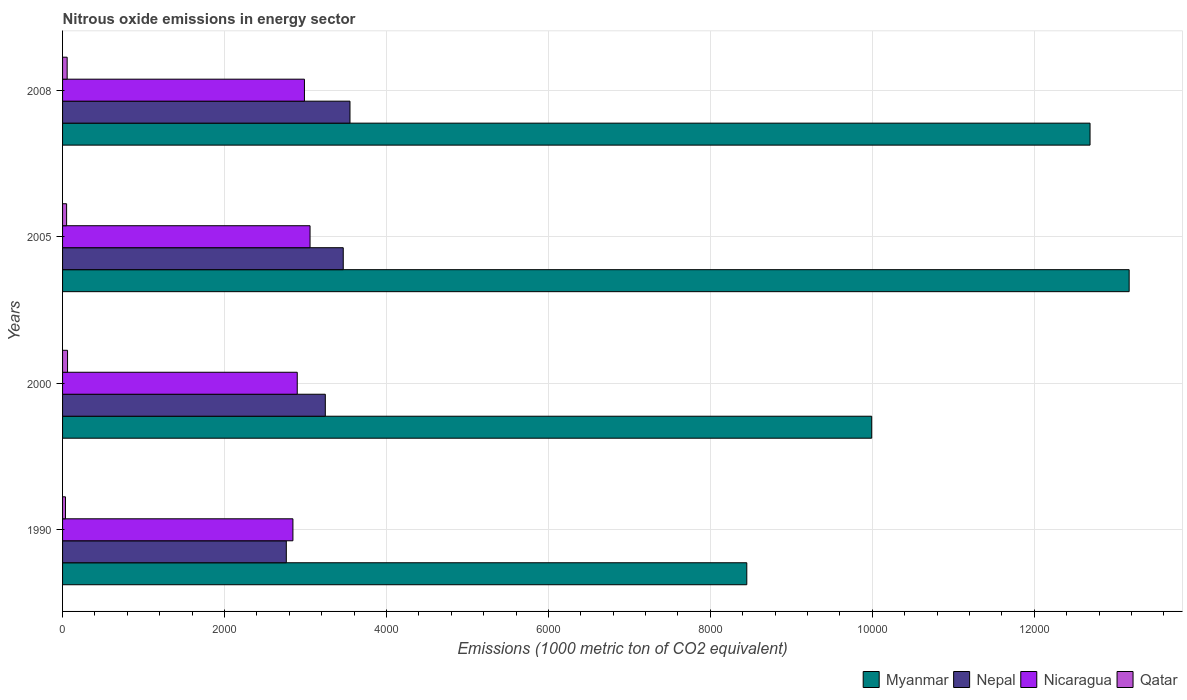How many different coloured bars are there?
Make the answer very short. 4. Are the number of bars per tick equal to the number of legend labels?
Provide a short and direct response. Yes. How many bars are there on the 4th tick from the bottom?
Provide a succinct answer. 4. What is the amount of nitrous oxide emitted in Nepal in 2008?
Your answer should be compact. 3549.4. Across all years, what is the maximum amount of nitrous oxide emitted in Nepal?
Your response must be concise. 3549.4. Across all years, what is the minimum amount of nitrous oxide emitted in Nicaragua?
Provide a succinct answer. 2844.7. In which year was the amount of nitrous oxide emitted in Qatar minimum?
Give a very brief answer. 1990. What is the total amount of nitrous oxide emitted in Nicaragua in the graph?
Provide a succinct answer. 1.18e+04. What is the difference between the amount of nitrous oxide emitted in Nicaragua in 2000 and that in 2005?
Your answer should be compact. -157.9. What is the difference between the amount of nitrous oxide emitted in Myanmar in 1990 and the amount of nitrous oxide emitted in Nicaragua in 2000?
Keep it short and to the point. 5551.5. What is the average amount of nitrous oxide emitted in Nepal per year?
Your answer should be compact. 3255.85. In the year 1990, what is the difference between the amount of nitrous oxide emitted in Nicaragua and amount of nitrous oxide emitted in Qatar?
Keep it short and to the point. 2808.7. In how many years, is the amount of nitrous oxide emitted in Qatar greater than 12000 1000 metric ton?
Give a very brief answer. 0. What is the ratio of the amount of nitrous oxide emitted in Nepal in 1990 to that in 2008?
Give a very brief answer. 0.78. Is the difference between the amount of nitrous oxide emitted in Nicaragua in 1990 and 2008 greater than the difference between the amount of nitrous oxide emitted in Qatar in 1990 and 2008?
Your answer should be very brief. No. What is the difference between the highest and the second highest amount of nitrous oxide emitted in Nicaragua?
Your answer should be very brief. 69.2. What is the difference between the highest and the lowest amount of nitrous oxide emitted in Myanmar?
Provide a short and direct response. 4721.9. In how many years, is the amount of nitrous oxide emitted in Nepal greater than the average amount of nitrous oxide emitted in Nepal taken over all years?
Your answer should be compact. 2. Is the sum of the amount of nitrous oxide emitted in Nicaragua in 2005 and 2008 greater than the maximum amount of nitrous oxide emitted in Myanmar across all years?
Your answer should be very brief. No. What does the 4th bar from the top in 2000 represents?
Offer a terse response. Myanmar. What does the 4th bar from the bottom in 2008 represents?
Offer a terse response. Qatar. What is the difference between two consecutive major ticks on the X-axis?
Your answer should be very brief. 2000. Are the values on the major ticks of X-axis written in scientific E-notation?
Ensure brevity in your answer.  No. Does the graph contain any zero values?
Make the answer very short. No. What is the title of the graph?
Offer a terse response. Nitrous oxide emissions in energy sector. What is the label or title of the X-axis?
Offer a terse response. Emissions (1000 metric ton of CO2 equivalent). What is the Emissions (1000 metric ton of CO2 equivalent) in Myanmar in 1990?
Offer a terse response. 8449.7. What is the Emissions (1000 metric ton of CO2 equivalent) in Nepal in 1990?
Make the answer very short. 2763. What is the Emissions (1000 metric ton of CO2 equivalent) in Nicaragua in 1990?
Give a very brief answer. 2844.7. What is the Emissions (1000 metric ton of CO2 equivalent) in Qatar in 1990?
Offer a terse response. 36. What is the Emissions (1000 metric ton of CO2 equivalent) of Myanmar in 2000?
Your answer should be compact. 9992.2. What is the Emissions (1000 metric ton of CO2 equivalent) of Nepal in 2000?
Provide a succinct answer. 3244.8. What is the Emissions (1000 metric ton of CO2 equivalent) in Nicaragua in 2000?
Provide a succinct answer. 2898.2. What is the Emissions (1000 metric ton of CO2 equivalent) of Qatar in 2000?
Make the answer very short. 61.6. What is the Emissions (1000 metric ton of CO2 equivalent) in Myanmar in 2005?
Your answer should be compact. 1.32e+04. What is the Emissions (1000 metric ton of CO2 equivalent) of Nepal in 2005?
Keep it short and to the point. 3466.2. What is the Emissions (1000 metric ton of CO2 equivalent) of Nicaragua in 2005?
Your answer should be very brief. 3056.1. What is the Emissions (1000 metric ton of CO2 equivalent) in Qatar in 2005?
Keep it short and to the point. 49.9. What is the Emissions (1000 metric ton of CO2 equivalent) in Myanmar in 2008?
Make the answer very short. 1.27e+04. What is the Emissions (1000 metric ton of CO2 equivalent) in Nepal in 2008?
Provide a short and direct response. 3549.4. What is the Emissions (1000 metric ton of CO2 equivalent) in Nicaragua in 2008?
Offer a very short reply. 2986.9. What is the Emissions (1000 metric ton of CO2 equivalent) in Qatar in 2008?
Offer a very short reply. 56.6. Across all years, what is the maximum Emissions (1000 metric ton of CO2 equivalent) of Myanmar?
Your answer should be very brief. 1.32e+04. Across all years, what is the maximum Emissions (1000 metric ton of CO2 equivalent) in Nepal?
Your answer should be compact. 3549.4. Across all years, what is the maximum Emissions (1000 metric ton of CO2 equivalent) of Nicaragua?
Provide a succinct answer. 3056.1. Across all years, what is the maximum Emissions (1000 metric ton of CO2 equivalent) of Qatar?
Offer a terse response. 61.6. Across all years, what is the minimum Emissions (1000 metric ton of CO2 equivalent) of Myanmar?
Ensure brevity in your answer.  8449.7. Across all years, what is the minimum Emissions (1000 metric ton of CO2 equivalent) of Nepal?
Your response must be concise. 2763. Across all years, what is the minimum Emissions (1000 metric ton of CO2 equivalent) in Nicaragua?
Your answer should be compact. 2844.7. Across all years, what is the minimum Emissions (1000 metric ton of CO2 equivalent) of Qatar?
Keep it short and to the point. 36. What is the total Emissions (1000 metric ton of CO2 equivalent) in Myanmar in the graph?
Your answer should be very brief. 4.43e+04. What is the total Emissions (1000 metric ton of CO2 equivalent) in Nepal in the graph?
Provide a succinct answer. 1.30e+04. What is the total Emissions (1000 metric ton of CO2 equivalent) of Nicaragua in the graph?
Give a very brief answer. 1.18e+04. What is the total Emissions (1000 metric ton of CO2 equivalent) of Qatar in the graph?
Provide a succinct answer. 204.1. What is the difference between the Emissions (1000 metric ton of CO2 equivalent) in Myanmar in 1990 and that in 2000?
Ensure brevity in your answer.  -1542.5. What is the difference between the Emissions (1000 metric ton of CO2 equivalent) of Nepal in 1990 and that in 2000?
Your answer should be compact. -481.8. What is the difference between the Emissions (1000 metric ton of CO2 equivalent) in Nicaragua in 1990 and that in 2000?
Your response must be concise. -53.5. What is the difference between the Emissions (1000 metric ton of CO2 equivalent) in Qatar in 1990 and that in 2000?
Your response must be concise. -25.6. What is the difference between the Emissions (1000 metric ton of CO2 equivalent) in Myanmar in 1990 and that in 2005?
Offer a terse response. -4721.9. What is the difference between the Emissions (1000 metric ton of CO2 equivalent) of Nepal in 1990 and that in 2005?
Provide a succinct answer. -703.2. What is the difference between the Emissions (1000 metric ton of CO2 equivalent) in Nicaragua in 1990 and that in 2005?
Ensure brevity in your answer.  -211.4. What is the difference between the Emissions (1000 metric ton of CO2 equivalent) in Qatar in 1990 and that in 2005?
Ensure brevity in your answer.  -13.9. What is the difference between the Emissions (1000 metric ton of CO2 equivalent) of Myanmar in 1990 and that in 2008?
Provide a succinct answer. -4238.8. What is the difference between the Emissions (1000 metric ton of CO2 equivalent) of Nepal in 1990 and that in 2008?
Offer a very short reply. -786.4. What is the difference between the Emissions (1000 metric ton of CO2 equivalent) of Nicaragua in 1990 and that in 2008?
Offer a terse response. -142.2. What is the difference between the Emissions (1000 metric ton of CO2 equivalent) in Qatar in 1990 and that in 2008?
Offer a very short reply. -20.6. What is the difference between the Emissions (1000 metric ton of CO2 equivalent) of Myanmar in 2000 and that in 2005?
Offer a terse response. -3179.4. What is the difference between the Emissions (1000 metric ton of CO2 equivalent) in Nepal in 2000 and that in 2005?
Make the answer very short. -221.4. What is the difference between the Emissions (1000 metric ton of CO2 equivalent) of Nicaragua in 2000 and that in 2005?
Give a very brief answer. -157.9. What is the difference between the Emissions (1000 metric ton of CO2 equivalent) in Qatar in 2000 and that in 2005?
Offer a very short reply. 11.7. What is the difference between the Emissions (1000 metric ton of CO2 equivalent) of Myanmar in 2000 and that in 2008?
Your answer should be very brief. -2696.3. What is the difference between the Emissions (1000 metric ton of CO2 equivalent) of Nepal in 2000 and that in 2008?
Your answer should be very brief. -304.6. What is the difference between the Emissions (1000 metric ton of CO2 equivalent) of Nicaragua in 2000 and that in 2008?
Your response must be concise. -88.7. What is the difference between the Emissions (1000 metric ton of CO2 equivalent) of Qatar in 2000 and that in 2008?
Give a very brief answer. 5. What is the difference between the Emissions (1000 metric ton of CO2 equivalent) in Myanmar in 2005 and that in 2008?
Give a very brief answer. 483.1. What is the difference between the Emissions (1000 metric ton of CO2 equivalent) in Nepal in 2005 and that in 2008?
Offer a terse response. -83.2. What is the difference between the Emissions (1000 metric ton of CO2 equivalent) of Nicaragua in 2005 and that in 2008?
Keep it short and to the point. 69.2. What is the difference between the Emissions (1000 metric ton of CO2 equivalent) of Myanmar in 1990 and the Emissions (1000 metric ton of CO2 equivalent) of Nepal in 2000?
Provide a succinct answer. 5204.9. What is the difference between the Emissions (1000 metric ton of CO2 equivalent) in Myanmar in 1990 and the Emissions (1000 metric ton of CO2 equivalent) in Nicaragua in 2000?
Ensure brevity in your answer.  5551.5. What is the difference between the Emissions (1000 metric ton of CO2 equivalent) in Myanmar in 1990 and the Emissions (1000 metric ton of CO2 equivalent) in Qatar in 2000?
Give a very brief answer. 8388.1. What is the difference between the Emissions (1000 metric ton of CO2 equivalent) in Nepal in 1990 and the Emissions (1000 metric ton of CO2 equivalent) in Nicaragua in 2000?
Offer a terse response. -135.2. What is the difference between the Emissions (1000 metric ton of CO2 equivalent) in Nepal in 1990 and the Emissions (1000 metric ton of CO2 equivalent) in Qatar in 2000?
Your answer should be very brief. 2701.4. What is the difference between the Emissions (1000 metric ton of CO2 equivalent) in Nicaragua in 1990 and the Emissions (1000 metric ton of CO2 equivalent) in Qatar in 2000?
Keep it short and to the point. 2783.1. What is the difference between the Emissions (1000 metric ton of CO2 equivalent) in Myanmar in 1990 and the Emissions (1000 metric ton of CO2 equivalent) in Nepal in 2005?
Offer a terse response. 4983.5. What is the difference between the Emissions (1000 metric ton of CO2 equivalent) of Myanmar in 1990 and the Emissions (1000 metric ton of CO2 equivalent) of Nicaragua in 2005?
Give a very brief answer. 5393.6. What is the difference between the Emissions (1000 metric ton of CO2 equivalent) of Myanmar in 1990 and the Emissions (1000 metric ton of CO2 equivalent) of Qatar in 2005?
Offer a terse response. 8399.8. What is the difference between the Emissions (1000 metric ton of CO2 equivalent) in Nepal in 1990 and the Emissions (1000 metric ton of CO2 equivalent) in Nicaragua in 2005?
Give a very brief answer. -293.1. What is the difference between the Emissions (1000 metric ton of CO2 equivalent) of Nepal in 1990 and the Emissions (1000 metric ton of CO2 equivalent) of Qatar in 2005?
Offer a terse response. 2713.1. What is the difference between the Emissions (1000 metric ton of CO2 equivalent) in Nicaragua in 1990 and the Emissions (1000 metric ton of CO2 equivalent) in Qatar in 2005?
Offer a very short reply. 2794.8. What is the difference between the Emissions (1000 metric ton of CO2 equivalent) of Myanmar in 1990 and the Emissions (1000 metric ton of CO2 equivalent) of Nepal in 2008?
Give a very brief answer. 4900.3. What is the difference between the Emissions (1000 metric ton of CO2 equivalent) of Myanmar in 1990 and the Emissions (1000 metric ton of CO2 equivalent) of Nicaragua in 2008?
Your response must be concise. 5462.8. What is the difference between the Emissions (1000 metric ton of CO2 equivalent) in Myanmar in 1990 and the Emissions (1000 metric ton of CO2 equivalent) in Qatar in 2008?
Keep it short and to the point. 8393.1. What is the difference between the Emissions (1000 metric ton of CO2 equivalent) of Nepal in 1990 and the Emissions (1000 metric ton of CO2 equivalent) of Nicaragua in 2008?
Your answer should be compact. -223.9. What is the difference between the Emissions (1000 metric ton of CO2 equivalent) in Nepal in 1990 and the Emissions (1000 metric ton of CO2 equivalent) in Qatar in 2008?
Your answer should be compact. 2706.4. What is the difference between the Emissions (1000 metric ton of CO2 equivalent) in Nicaragua in 1990 and the Emissions (1000 metric ton of CO2 equivalent) in Qatar in 2008?
Provide a short and direct response. 2788.1. What is the difference between the Emissions (1000 metric ton of CO2 equivalent) in Myanmar in 2000 and the Emissions (1000 metric ton of CO2 equivalent) in Nepal in 2005?
Your response must be concise. 6526. What is the difference between the Emissions (1000 metric ton of CO2 equivalent) in Myanmar in 2000 and the Emissions (1000 metric ton of CO2 equivalent) in Nicaragua in 2005?
Your answer should be very brief. 6936.1. What is the difference between the Emissions (1000 metric ton of CO2 equivalent) of Myanmar in 2000 and the Emissions (1000 metric ton of CO2 equivalent) of Qatar in 2005?
Make the answer very short. 9942.3. What is the difference between the Emissions (1000 metric ton of CO2 equivalent) of Nepal in 2000 and the Emissions (1000 metric ton of CO2 equivalent) of Nicaragua in 2005?
Your answer should be very brief. 188.7. What is the difference between the Emissions (1000 metric ton of CO2 equivalent) of Nepal in 2000 and the Emissions (1000 metric ton of CO2 equivalent) of Qatar in 2005?
Keep it short and to the point. 3194.9. What is the difference between the Emissions (1000 metric ton of CO2 equivalent) of Nicaragua in 2000 and the Emissions (1000 metric ton of CO2 equivalent) of Qatar in 2005?
Your response must be concise. 2848.3. What is the difference between the Emissions (1000 metric ton of CO2 equivalent) in Myanmar in 2000 and the Emissions (1000 metric ton of CO2 equivalent) in Nepal in 2008?
Provide a short and direct response. 6442.8. What is the difference between the Emissions (1000 metric ton of CO2 equivalent) of Myanmar in 2000 and the Emissions (1000 metric ton of CO2 equivalent) of Nicaragua in 2008?
Provide a succinct answer. 7005.3. What is the difference between the Emissions (1000 metric ton of CO2 equivalent) in Myanmar in 2000 and the Emissions (1000 metric ton of CO2 equivalent) in Qatar in 2008?
Offer a very short reply. 9935.6. What is the difference between the Emissions (1000 metric ton of CO2 equivalent) in Nepal in 2000 and the Emissions (1000 metric ton of CO2 equivalent) in Nicaragua in 2008?
Make the answer very short. 257.9. What is the difference between the Emissions (1000 metric ton of CO2 equivalent) in Nepal in 2000 and the Emissions (1000 metric ton of CO2 equivalent) in Qatar in 2008?
Offer a very short reply. 3188.2. What is the difference between the Emissions (1000 metric ton of CO2 equivalent) of Nicaragua in 2000 and the Emissions (1000 metric ton of CO2 equivalent) of Qatar in 2008?
Provide a succinct answer. 2841.6. What is the difference between the Emissions (1000 metric ton of CO2 equivalent) of Myanmar in 2005 and the Emissions (1000 metric ton of CO2 equivalent) of Nepal in 2008?
Offer a very short reply. 9622.2. What is the difference between the Emissions (1000 metric ton of CO2 equivalent) in Myanmar in 2005 and the Emissions (1000 metric ton of CO2 equivalent) in Nicaragua in 2008?
Ensure brevity in your answer.  1.02e+04. What is the difference between the Emissions (1000 metric ton of CO2 equivalent) in Myanmar in 2005 and the Emissions (1000 metric ton of CO2 equivalent) in Qatar in 2008?
Your response must be concise. 1.31e+04. What is the difference between the Emissions (1000 metric ton of CO2 equivalent) in Nepal in 2005 and the Emissions (1000 metric ton of CO2 equivalent) in Nicaragua in 2008?
Keep it short and to the point. 479.3. What is the difference between the Emissions (1000 metric ton of CO2 equivalent) in Nepal in 2005 and the Emissions (1000 metric ton of CO2 equivalent) in Qatar in 2008?
Give a very brief answer. 3409.6. What is the difference between the Emissions (1000 metric ton of CO2 equivalent) of Nicaragua in 2005 and the Emissions (1000 metric ton of CO2 equivalent) of Qatar in 2008?
Provide a succinct answer. 2999.5. What is the average Emissions (1000 metric ton of CO2 equivalent) of Myanmar per year?
Ensure brevity in your answer.  1.11e+04. What is the average Emissions (1000 metric ton of CO2 equivalent) of Nepal per year?
Offer a very short reply. 3255.85. What is the average Emissions (1000 metric ton of CO2 equivalent) in Nicaragua per year?
Make the answer very short. 2946.47. What is the average Emissions (1000 metric ton of CO2 equivalent) in Qatar per year?
Your response must be concise. 51.02. In the year 1990, what is the difference between the Emissions (1000 metric ton of CO2 equivalent) in Myanmar and Emissions (1000 metric ton of CO2 equivalent) in Nepal?
Provide a short and direct response. 5686.7. In the year 1990, what is the difference between the Emissions (1000 metric ton of CO2 equivalent) of Myanmar and Emissions (1000 metric ton of CO2 equivalent) of Nicaragua?
Your answer should be very brief. 5605. In the year 1990, what is the difference between the Emissions (1000 metric ton of CO2 equivalent) in Myanmar and Emissions (1000 metric ton of CO2 equivalent) in Qatar?
Keep it short and to the point. 8413.7. In the year 1990, what is the difference between the Emissions (1000 metric ton of CO2 equivalent) of Nepal and Emissions (1000 metric ton of CO2 equivalent) of Nicaragua?
Your response must be concise. -81.7. In the year 1990, what is the difference between the Emissions (1000 metric ton of CO2 equivalent) in Nepal and Emissions (1000 metric ton of CO2 equivalent) in Qatar?
Keep it short and to the point. 2727. In the year 1990, what is the difference between the Emissions (1000 metric ton of CO2 equivalent) in Nicaragua and Emissions (1000 metric ton of CO2 equivalent) in Qatar?
Give a very brief answer. 2808.7. In the year 2000, what is the difference between the Emissions (1000 metric ton of CO2 equivalent) of Myanmar and Emissions (1000 metric ton of CO2 equivalent) of Nepal?
Provide a succinct answer. 6747.4. In the year 2000, what is the difference between the Emissions (1000 metric ton of CO2 equivalent) of Myanmar and Emissions (1000 metric ton of CO2 equivalent) of Nicaragua?
Your response must be concise. 7094. In the year 2000, what is the difference between the Emissions (1000 metric ton of CO2 equivalent) in Myanmar and Emissions (1000 metric ton of CO2 equivalent) in Qatar?
Your answer should be very brief. 9930.6. In the year 2000, what is the difference between the Emissions (1000 metric ton of CO2 equivalent) of Nepal and Emissions (1000 metric ton of CO2 equivalent) of Nicaragua?
Give a very brief answer. 346.6. In the year 2000, what is the difference between the Emissions (1000 metric ton of CO2 equivalent) of Nepal and Emissions (1000 metric ton of CO2 equivalent) of Qatar?
Your answer should be compact. 3183.2. In the year 2000, what is the difference between the Emissions (1000 metric ton of CO2 equivalent) in Nicaragua and Emissions (1000 metric ton of CO2 equivalent) in Qatar?
Your response must be concise. 2836.6. In the year 2005, what is the difference between the Emissions (1000 metric ton of CO2 equivalent) of Myanmar and Emissions (1000 metric ton of CO2 equivalent) of Nepal?
Provide a succinct answer. 9705.4. In the year 2005, what is the difference between the Emissions (1000 metric ton of CO2 equivalent) in Myanmar and Emissions (1000 metric ton of CO2 equivalent) in Nicaragua?
Ensure brevity in your answer.  1.01e+04. In the year 2005, what is the difference between the Emissions (1000 metric ton of CO2 equivalent) in Myanmar and Emissions (1000 metric ton of CO2 equivalent) in Qatar?
Ensure brevity in your answer.  1.31e+04. In the year 2005, what is the difference between the Emissions (1000 metric ton of CO2 equivalent) in Nepal and Emissions (1000 metric ton of CO2 equivalent) in Nicaragua?
Your response must be concise. 410.1. In the year 2005, what is the difference between the Emissions (1000 metric ton of CO2 equivalent) of Nepal and Emissions (1000 metric ton of CO2 equivalent) of Qatar?
Give a very brief answer. 3416.3. In the year 2005, what is the difference between the Emissions (1000 metric ton of CO2 equivalent) of Nicaragua and Emissions (1000 metric ton of CO2 equivalent) of Qatar?
Provide a short and direct response. 3006.2. In the year 2008, what is the difference between the Emissions (1000 metric ton of CO2 equivalent) of Myanmar and Emissions (1000 metric ton of CO2 equivalent) of Nepal?
Offer a terse response. 9139.1. In the year 2008, what is the difference between the Emissions (1000 metric ton of CO2 equivalent) in Myanmar and Emissions (1000 metric ton of CO2 equivalent) in Nicaragua?
Offer a very short reply. 9701.6. In the year 2008, what is the difference between the Emissions (1000 metric ton of CO2 equivalent) in Myanmar and Emissions (1000 metric ton of CO2 equivalent) in Qatar?
Your answer should be very brief. 1.26e+04. In the year 2008, what is the difference between the Emissions (1000 metric ton of CO2 equivalent) in Nepal and Emissions (1000 metric ton of CO2 equivalent) in Nicaragua?
Make the answer very short. 562.5. In the year 2008, what is the difference between the Emissions (1000 metric ton of CO2 equivalent) of Nepal and Emissions (1000 metric ton of CO2 equivalent) of Qatar?
Keep it short and to the point. 3492.8. In the year 2008, what is the difference between the Emissions (1000 metric ton of CO2 equivalent) in Nicaragua and Emissions (1000 metric ton of CO2 equivalent) in Qatar?
Give a very brief answer. 2930.3. What is the ratio of the Emissions (1000 metric ton of CO2 equivalent) in Myanmar in 1990 to that in 2000?
Make the answer very short. 0.85. What is the ratio of the Emissions (1000 metric ton of CO2 equivalent) in Nepal in 1990 to that in 2000?
Ensure brevity in your answer.  0.85. What is the ratio of the Emissions (1000 metric ton of CO2 equivalent) of Nicaragua in 1990 to that in 2000?
Your response must be concise. 0.98. What is the ratio of the Emissions (1000 metric ton of CO2 equivalent) in Qatar in 1990 to that in 2000?
Provide a succinct answer. 0.58. What is the ratio of the Emissions (1000 metric ton of CO2 equivalent) of Myanmar in 1990 to that in 2005?
Offer a very short reply. 0.64. What is the ratio of the Emissions (1000 metric ton of CO2 equivalent) in Nepal in 1990 to that in 2005?
Your answer should be very brief. 0.8. What is the ratio of the Emissions (1000 metric ton of CO2 equivalent) in Nicaragua in 1990 to that in 2005?
Provide a short and direct response. 0.93. What is the ratio of the Emissions (1000 metric ton of CO2 equivalent) in Qatar in 1990 to that in 2005?
Ensure brevity in your answer.  0.72. What is the ratio of the Emissions (1000 metric ton of CO2 equivalent) of Myanmar in 1990 to that in 2008?
Offer a terse response. 0.67. What is the ratio of the Emissions (1000 metric ton of CO2 equivalent) in Nepal in 1990 to that in 2008?
Ensure brevity in your answer.  0.78. What is the ratio of the Emissions (1000 metric ton of CO2 equivalent) of Nicaragua in 1990 to that in 2008?
Offer a terse response. 0.95. What is the ratio of the Emissions (1000 metric ton of CO2 equivalent) in Qatar in 1990 to that in 2008?
Provide a short and direct response. 0.64. What is the ratio of the Emissions (1000 metric ton of CO2 equivalent) in Myanmar in 2000 to that in 2005?
Give a very brief answer. 0.76. What is the ratio of the Emissions (1000 metric ton of CO2 equivalent) in Nepal in 2000 to that in 2005?
Make the answer very short. 0.94. What is the ratio of the Emissions (1000 metric ton of CO2 equivalent) of Nicaragua in 2000 to that in 2005?
Ensure brevity in your answer.  0.95. What is the ratio of the Emissions (1000 metric ton of CO2 equivalent) in Qatar in 2000 to that in 2005?
Your answer should be compact. 1.23. What is the ratio of the Emissions (1000 metric ton of CO2 equivalent) of Myanmar in 2000 to that in 2008?
Keep it short and to the point. 0.79. What is the ratio of the Emissions (1000 metric ton of CO2 equivalent) in Nepal in 2000 to that in 2008?
Keep it short and to the point. 0.91. What is the ratio of the Emissions (1000 metric ton of CO2 equivalent) of Nicaragua in 2000 to that in 2008?
Provide a short and direct response. 0.97. What is the ratio of the Emissions (1000 metric ton of CO2 equivalent) of Qatar in 2000 to that in 2008?
Keep it short and to the point. 1.09. What is the ratio of the Emissions (1000 metric ton of CO2 equivalent) in Myanmar in 2005 to that in 2008?
Provide a succinct answer. 1.04. What is the ratio of the Emissions (1000 metric ton of CO2 equivalent) of Nepal in 2005 to that in 2008?
Keep it short and to the point. 0.98. What is the ratio of the Emissions (1000 metric ton of CO2 equivalent) of Nicaragua in 2005 to that in 2008?
Offer a very short reply. 1.02. What is the ratio of the Emissions (1000 metric ton of CO2 equivalent) in Qatar in 2005 to that in 2008?
Your answer should be very brief. 0.88. What is the difference between the highest and the second highest Emissions (1000 metric ton of CO2 equivalent) in Myanmar?
Your response must be concise. 483.1. What is the difference between the highest and the second highest Emissions (1000 metric ton of CO2 equivalent) of Nepal?
Provide a succinct answer. 83.2. What is the difference between the highest and the second highest Emissions (1000 metric ton of CO2 equivalent) in Nicaragua?
Provide a short and direct response. 69.2. What is the difference between the highest and the lowest Emissions (1000 metric ton of CO2 equivalent) of Myanmar?
Provide a short and direct response. 4721.9. What is the difference between the highest and the lowest Emissions (1000 metric ton of CO2 equivalent) of Nepal?
Keep it short and to the point. 786.4. What is the difference between the highest and the lowest Emissions (1000 metric ton of CO2 equivalent) in Nicaragua?
Make the answer very short. 211.4. What is the difference between the highest and the lowest Emissions (1000 metric ton of CO2 equivalent) in Qatar?
Provide a succinct answer. 25.6. 